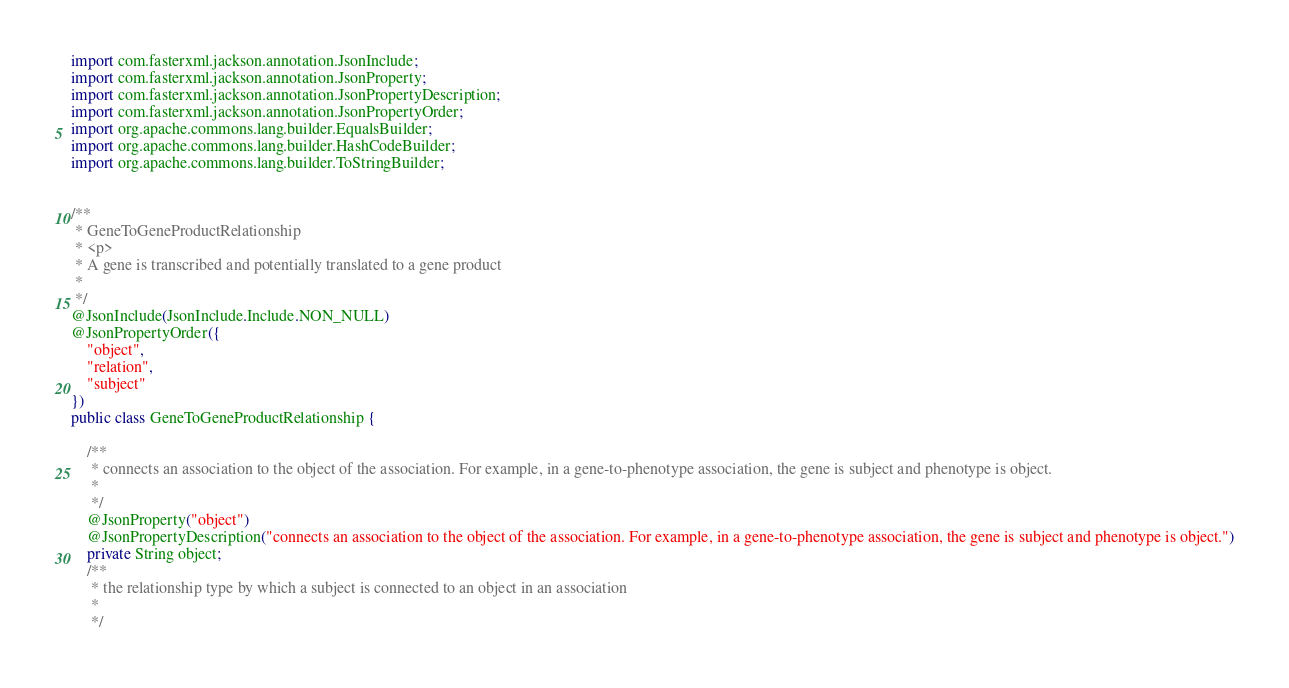<code> <loc_0><loc_0><loc_500><loc_500><_Java_>import com.fasterxml.jackson.annotation.JsonInclude;
import com.fasterxml.jackson.annotation.JsonProperty;
import com.fasterxml.jackson.annotation.JsonPropertyDescription;
import com.fasterxml.jackson.annotation.JsonPropertyOrder;
import org.apache.commons.lang.builder.EqualsBuilder;
import org.apache.commons.lang.builder.HashCodeBuilder;
import org.apache.commons.lang.builder.ToStringBuilder;


/**
 * GeneToGeneProductRelationship
 * <p>
 * A gene is transcribed and potentially translated to a gene product
 * 
 */
@JsonInclude(JsonInclude.Include.NON_NULL)
@JsonPropertyOrder({
    "object",
    "relation",
    "subject"
})
public class GeneToGeneProductRelationship {

    /**
     * connects an association to the object of the association. For example, in a gene-to-phenotype association, the gene is subject and phenotype is object.
     * 
     */
    @JsonProperty("object")
    @JsonPropertyDescription("connects an association to the object of the association. For example, in a gene-to-phenotype association, the gene is subject and phenotype is object.")
    private String object;
    /**
     * the relationship type by which a subject is connected to an object in an association
     * 
     */</code> 